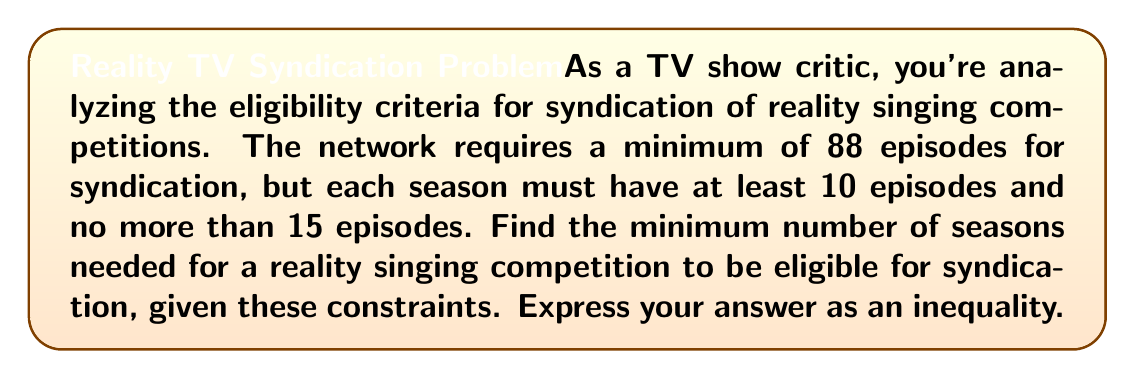Provide a solution to this math problem. Let's approach this step-by-step:

1) Let $x$ be the number of seasons.

2) Given that each season must have at least 10 episodes and no more than 15 episodes, we can express the total number of episodes as:

   $10x \leq \text{total episodes} \leq 15x$

3) For syndication, we need at least 88 episodes. So:

   $10x \leq 88 \leq 15x$

4) Let's focus on the left inequality: $10x \leq 88$
   Dividing both sides by 10:
   $x \leq 8.8$

5) Now, the right inequality: $88 \leq 15x$
   Dividing both sides by 15:
   $5.8666... \leq x$

6) Combining these inequalities:
   $5.8666... \leq x \leq 8.8$

7) Since $x$ represents the number of seasons, it must be a whole number. The smallest whole number greater than or equal to 5.8666... is 6.

Therefore, the minimum number of seasons needed is 6.

We can verify:
6 seasons * 15 episodes/season = 90 episodes, which is ≥ 88.
5 seasons * 15 episodes/season = 75 episodes, which is < 88.
Answer: $x \geq 6$, where $x$ is the number of seasons. 